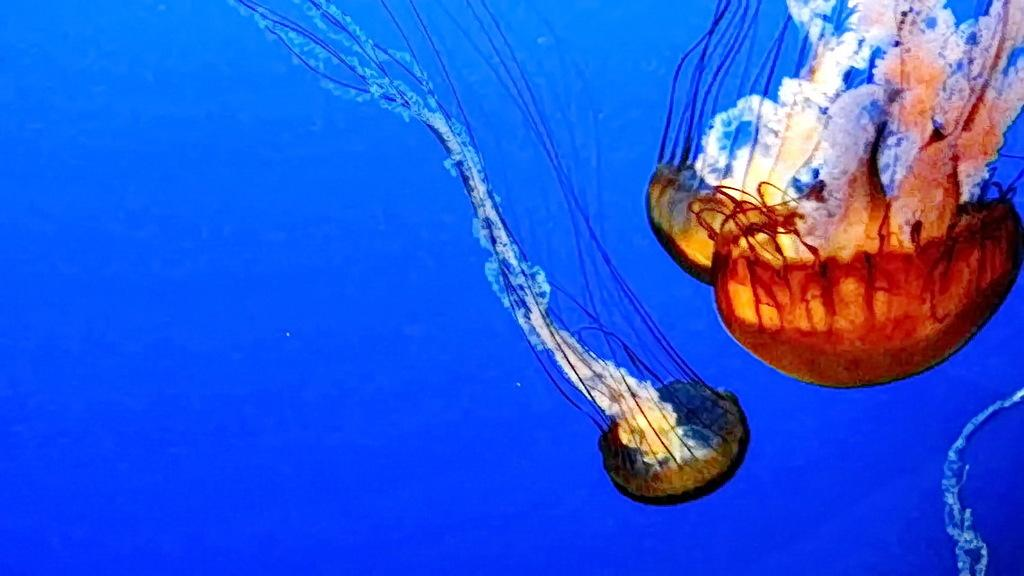What type of animals are in the image? There are jellyfishes in the image. What is the primary element in which the jellyfishes are situated? The jellyfishes are in water. What type of key is used to unlock the religious beliefs of the jellyfishes in the image? There is no key, religion, or any indication of beliefs in the image; it simply features jellyfishes in water. 